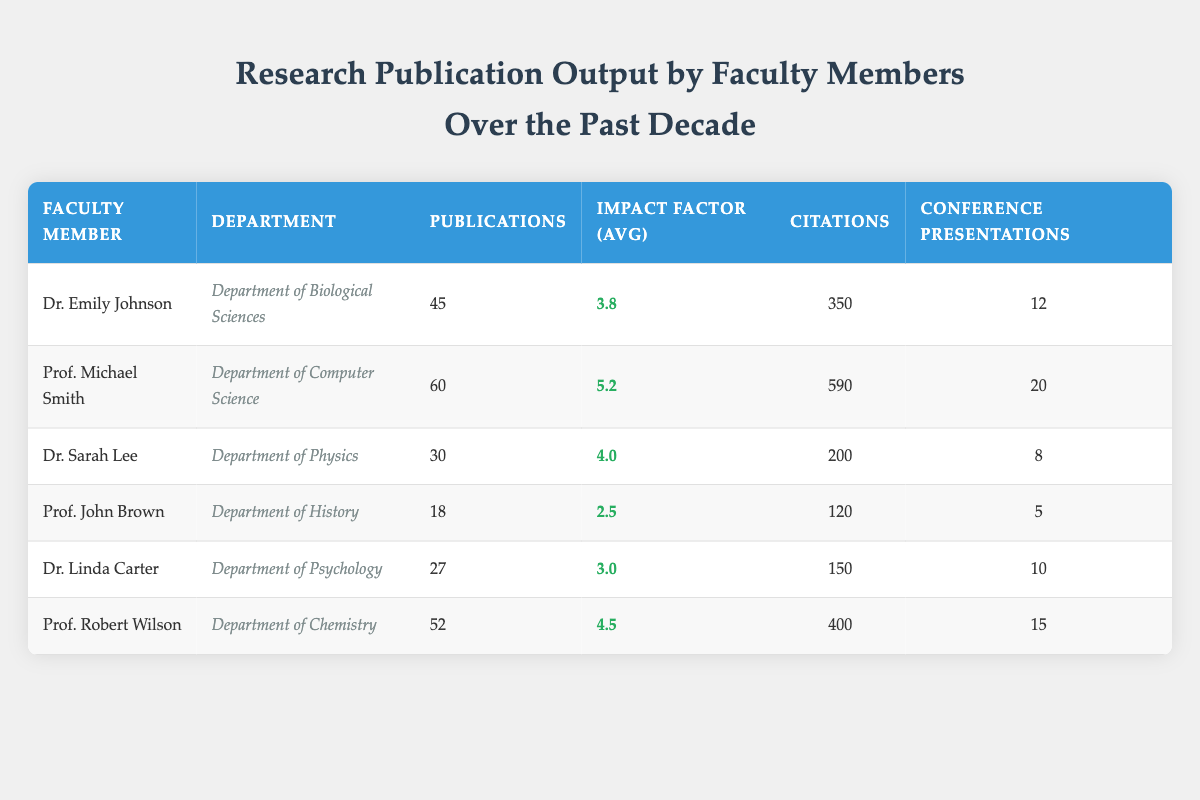What is the highest number of publications by a faculty member in the past decade? Looking at the "Publications" column, Prof. Michael Smith has the highest number of publications with 60, which is greater than the publications of any other faculty member.
Answer: 60 How many faculty members have an average impact factor above 4.0? By examining the "Impact Factor (Avg)" column, we see that three faculty members—Prof. Michael Smith, Dr. Sarah Lee, and Prof. Robert Wilson—have impact factors of 5.2, 4.0, and 4.5, respectively. Thus, there are two members with impact factors strictly above 4.0.
Answer: 2 What is the total number of conference presentations by all faculty members? To find the total number of conference presentations, we sum the presentations: 12 + 20 + 8 + 5 + 10 + 15 = 70. Therefore, the total is 70.
Answer: 70 Is it true that Dr. Emily Johnson has more citations than Prof. Robert Wilson? Checking the "Citations" column, Dr. Emily Johnson has 350 citations while Prof. Robert Wilson has 400 citations. Since 350 is less than 400, the statement is false.
Answer: False Who has the lowest average impact factor and what is that value? Looking through the "Impact Factor (Avg)" column, Prof. John Brown has the lowest average impact factor at 2.5. No other faculty member has a lower impact factor.
Answer: 2.5 Calculating the average number of publications across all faculty members, what do we get? We first sum the publications: 45 + 60 + 30 + 18 + 27 + 52 = 232. There are six faculty members, so we divide the total by 6. Thus, the average number of publications is 232/6, which is approximately 38.67.
Answer: 38.67 Which department has the highest total citations? To identify the department with the highest total citations, we summarize the citations: Biological Sciences (350), Computer Science (590), Physics (200), History (120), Psychology (150), and Chemistry (400). The highest total, 590, belongs to the Department of Computer Science.
Answer: Department of Computer Science How many total publications were contributed by the faculty members from the Department of Psychology and Department of History combined? From the "Publications" column, Dr. Linda Carter from Psychology has 27 publications and Prof. John Brown from History has 18. Adding these gives us 27 + 18 = 45 combined publications.
Answer: 45 